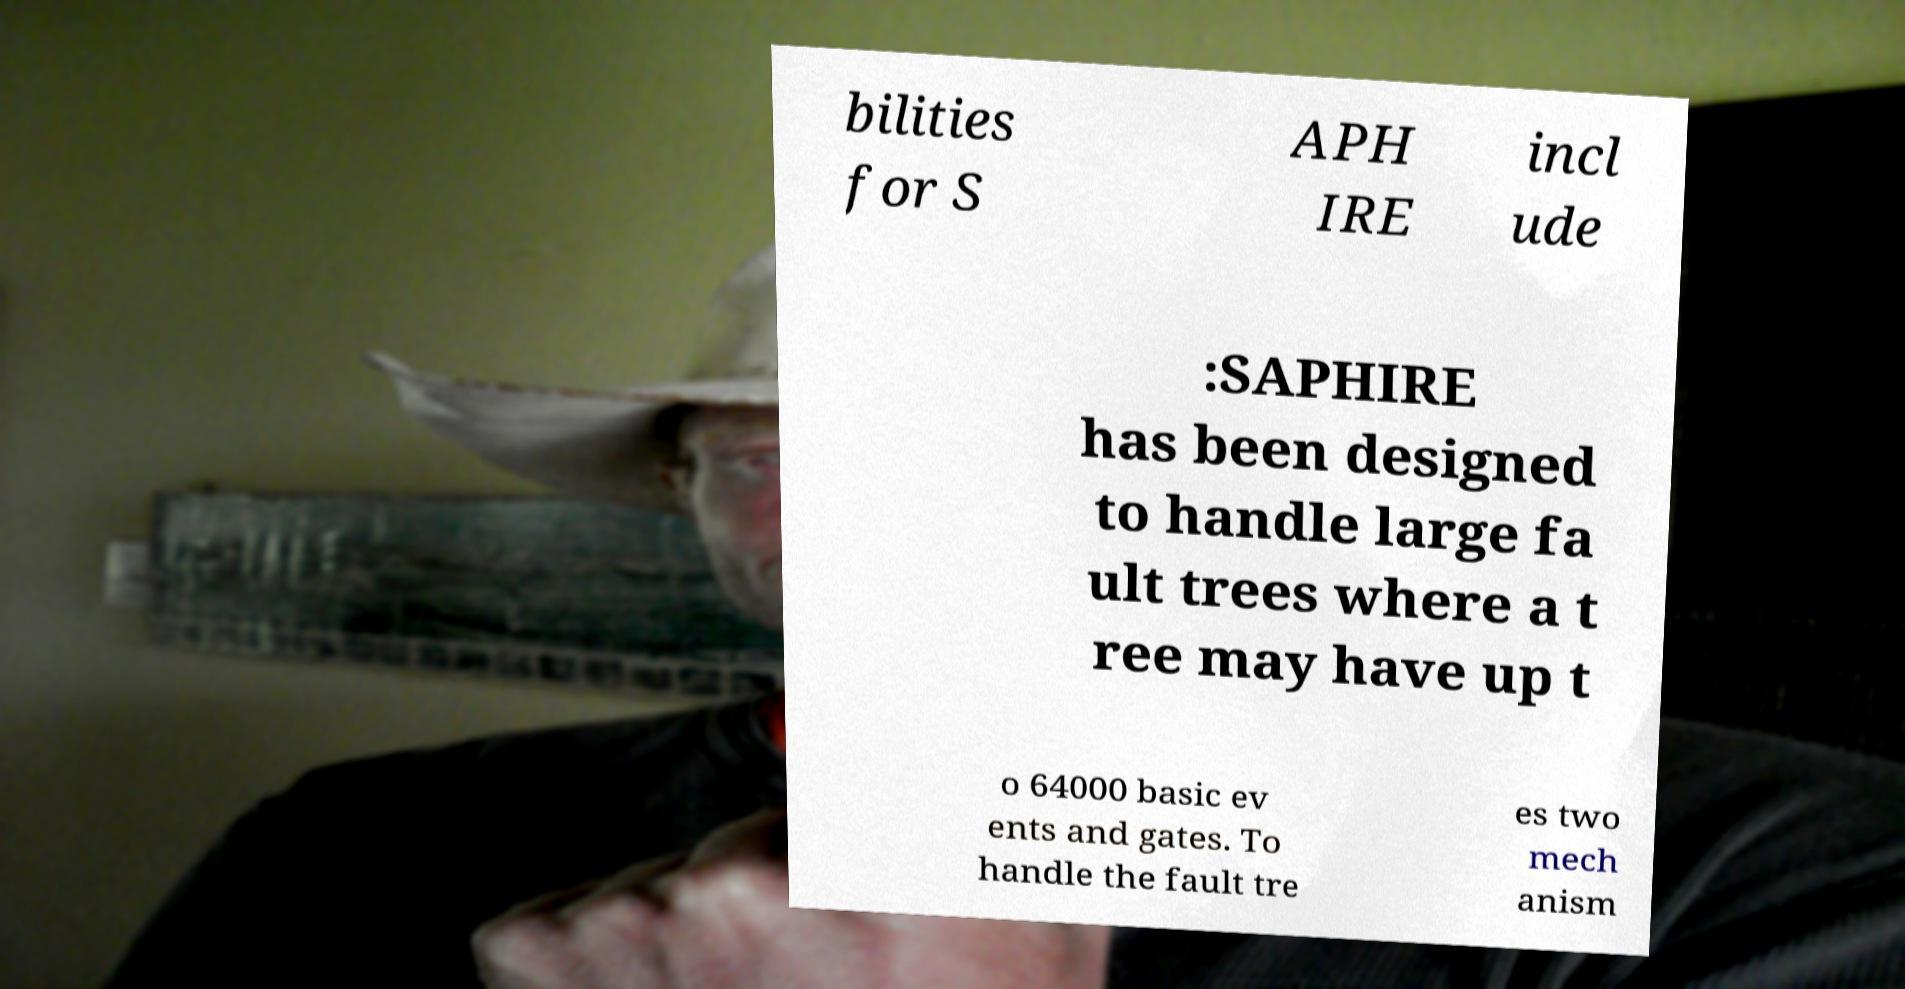There's text embedded in this image that I need extracted. Can you transcribe it verbatim? bilities for S APH IRE incl ude :SAPHIRE has been designed to handle large fa ult trees where a t ree may have up t o 64000 basic ev ents and gates. To handle the fault tre es two mech anism 